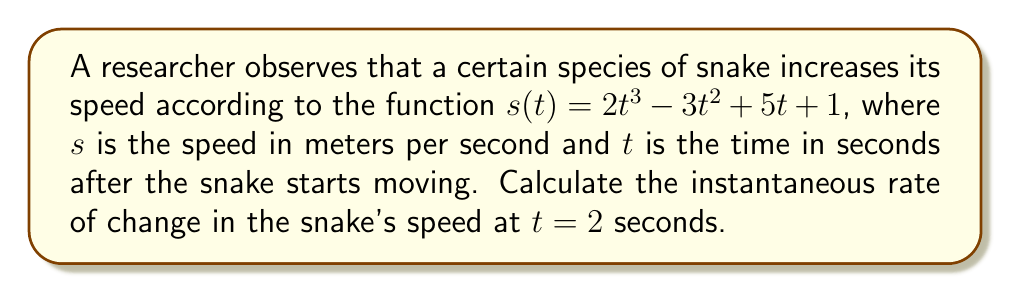Give your solution to this math problem. To find the instantaneous rate of change in the snake's speed at $t = 2$ seconds, we need to calculate the derivative of the speed function $s(t)$ and evaluate it at $t = 2$.

Step 1: Find the derivative of $s(t)$.
$$\frac{d}{dt}s(t) = \frac{d}{dt}(2t^3 - 3t^2 + 5t + 1)$$
$$s'(t) = 6t^2 - 6t + 5$$

Step 2: Evaluate $s'(t)$ at $t = 2$.
$$s'(2) = 6(2)^2 - 6(2) + 5$$
$$s'(2) = 6(4) - 12 + 5$$
$$s'(2) = 24 - 12 + 5$$
$$s'(2) = 17$$

Therefore, the instantaneous rate of change in the snake's speed at $t = 2$ seconds is 17 meters per second squared.
Answer: 17 m/s² 